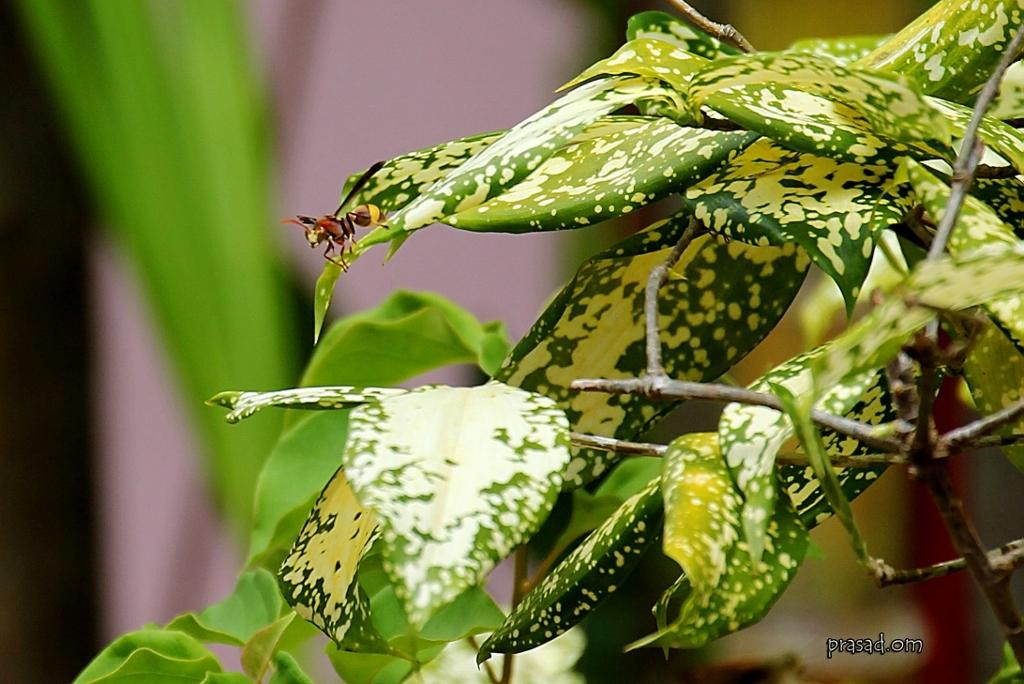What type of creature can be seen in the image? There is an insect in the image. What else is present in the image besides the insect? There are plants in the image. Can you describe the background of the image? The background of the image is blurred. What type of relation can be seen between the insect and the plants in the image? There is no indication of a relation between the insect and the plants in the image. The insect and plants are simply coexisting in the same space. 